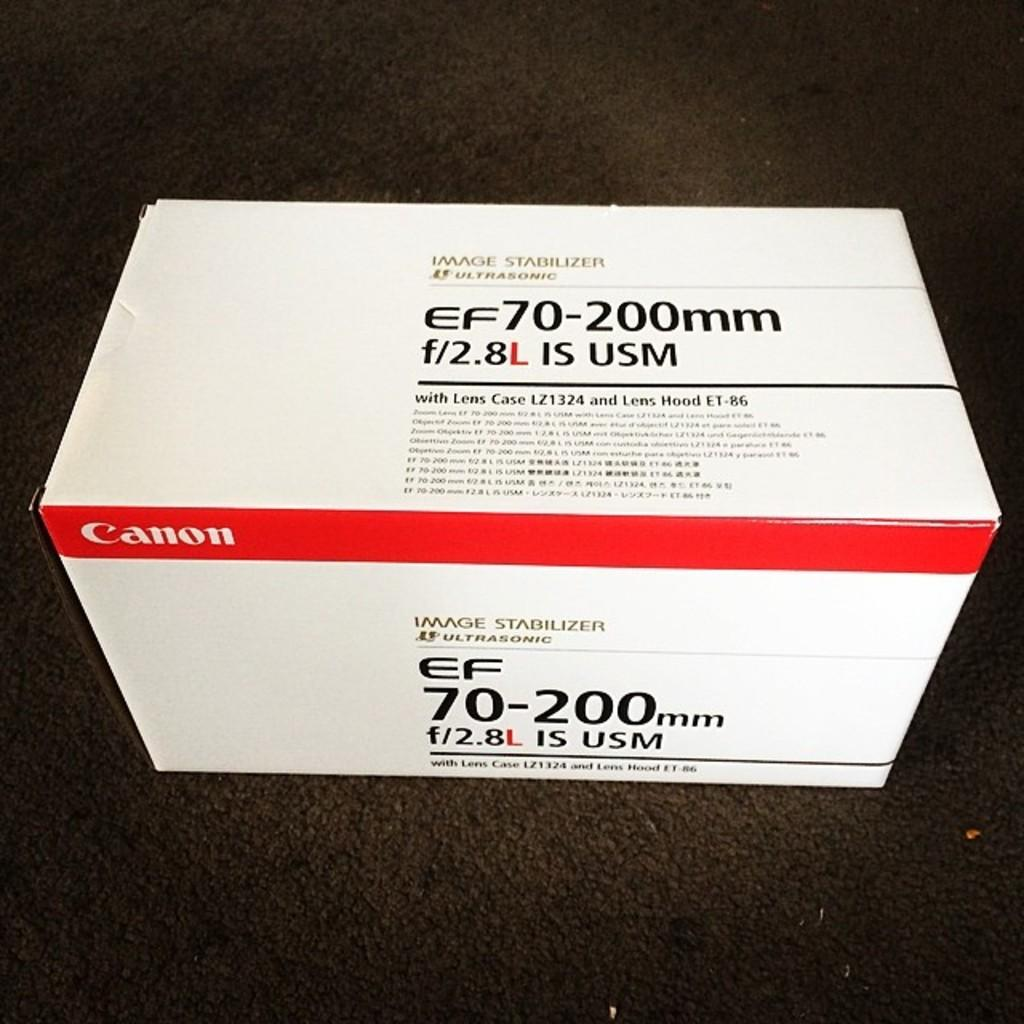<image>
Summarize the visual content of the image. Canon camera lens in the box and comes with a case according to the writing on the box. 